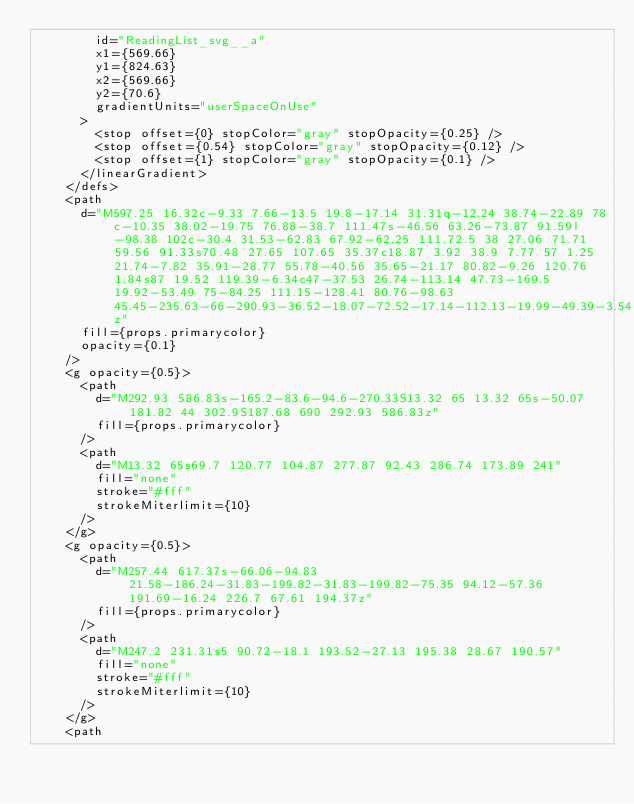<code> <loc_0><loc_0><loc_500><loc_500><_TypeScript_>        id="ReadingList_svg__a"
        x1={569.66}
        y1={824.63}
        x2={569.66}
        y2={70.6}
        gradientUnits="userSpaceOnUse"
      >
        <stop offset={0} stopColor="gray" stopOpacity={0.25} />
        <stop offset={0.54} stopColor="gray" stopOpacity={0.12} />
        <stop offset={1} stopColor="gray" stopOpacity={0.1} />
      </linearGradient>
    </defs>
    <path
      d="M597.25 16.32c-9.33 7.66-13.5 19.8-17.14 31.31q-12.24 38.74-22.89 78c-10.35 38.02-19.75 76.88-38.7 111.47s-46.56 63.26-73.87 91.59l-98.38 102c-30.4 31.53-62.83 67.92-62.25 111.72.5 38 27.06 71.71 59.56 91.33s70.48 27.65 107.65 35.37c18.87 3.92 38.9 7.77 57 1.25 21.74-7.82 35.91-28.77 55.78-40.56 35.65-21.17 80.82-9.26 120.76 1.84s87 19.52 119.39-6.34c47-37.53 26.74-113.14 47.73-169.5 19.92-53.49 75-84.25 111.15-128.41 80.76-98.63 45.45-235.63-66-290.93-36.52-18.07-72.52-17.14-112.13-19.99-49.39-3.54-145.09-35.12-187.66-.15z"
      fill={props.primarycolor}
      opacity={0.1}
    />
    <g opacity={0.5}>
      <path
        d="M292.93 586.83s-165.2-83.6-94.6-270.33S13.32 65 13.32 65s-50.07 181.82 44 302.9S187.68 690 292.93 586.83z"
        fill={props.primarycolor}
      />
      <path
        d="M13.32 65s69.7 120.77 104.87 277.87 92.43 286.74 173.89 241"
        fill="none"
        stroke="#fff"
        strokeMiterlimit={10}
      />
    </g>
    <g opacity={0.5}>
      <path
        d="M257.44 617.37s-66.06-94.83 21.58-186.24-31.83-199.82-31.83-199.82-75.35 94.12-57.36 191.69-16.24 226.7 67.61 194.37z"
        fill={props.primarycolor}
      />
      <path
        d="M247.2 231.31s5 90.72-18.1 193.52-27.13 195.38 28.67 190.57"
        fill="none"
        stroke="#fff"
        strokeMiterlimit={10}
      />
    </g>
    <path</code> 